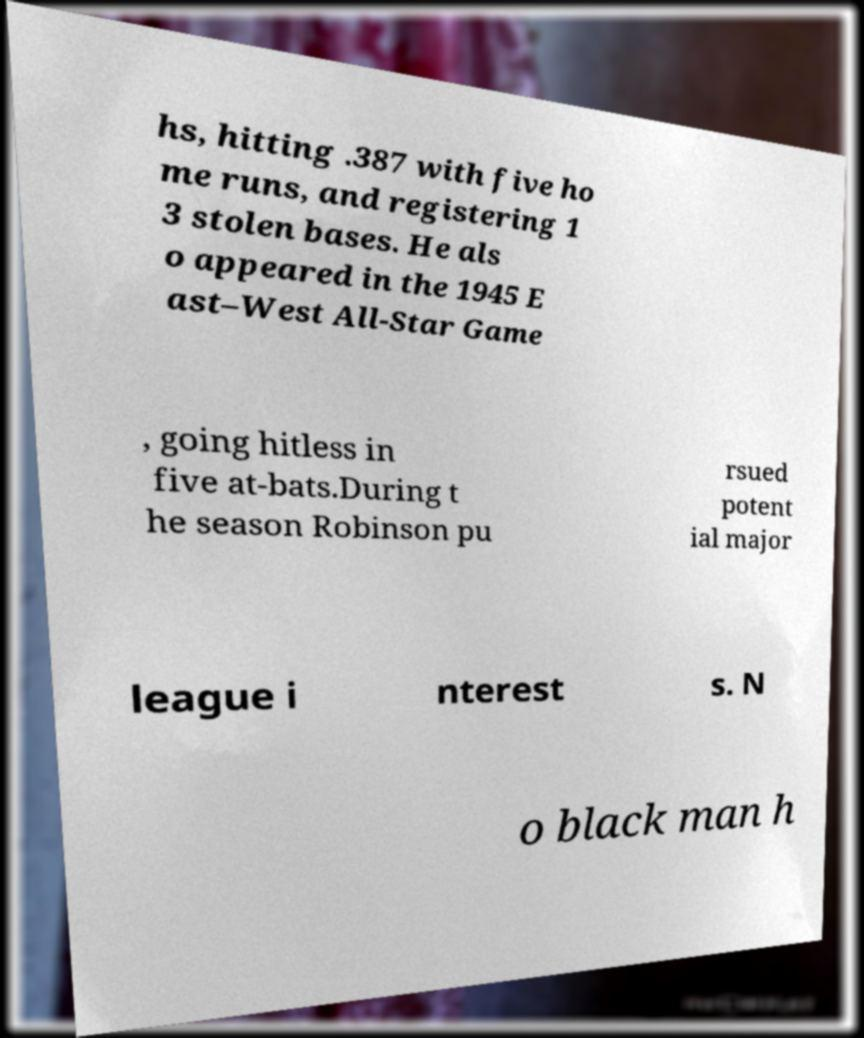Can you read and provide the text displayed in the image?This photo seems to have some interesting text. Can you extract and type it out for me? hs, hitting .387 with five ho me runs, and registering 1 3 stolen bases. He als o appeared in the 1945 E ast–West All-Star Game , going hitless in five at-bats.During t he season Robinson pu rsued potent ial major league i nterest s. N o black man h 